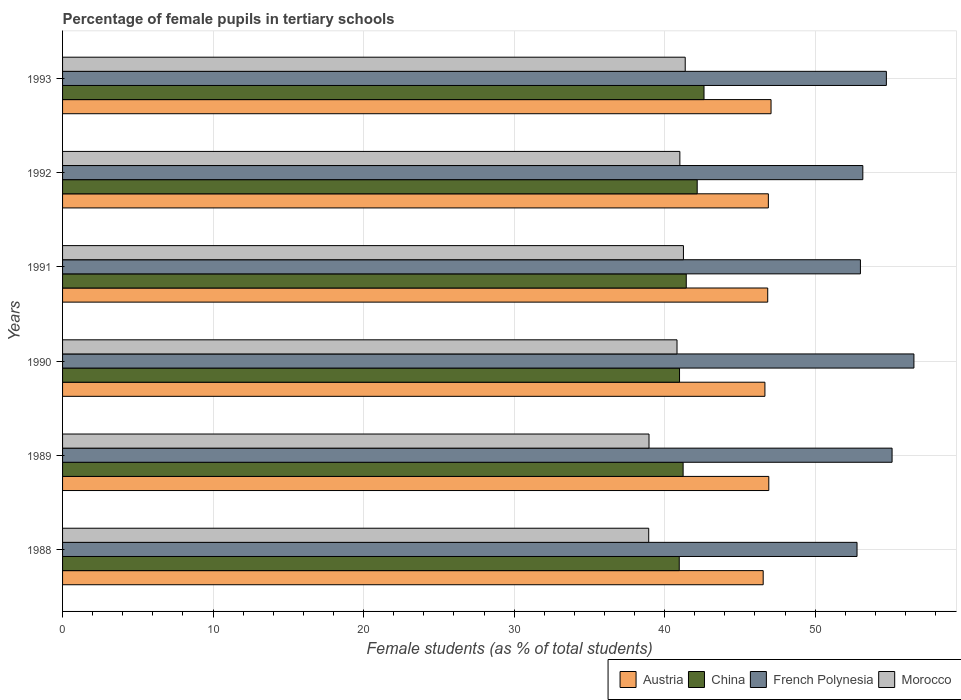Are the number of bars on each tick of the Y-axis equal?
Offer a terse response. Yes. In how many cases, is the number of bars for a given year not equal to the number of legend labels?
Give a very brief answer. 0. What is the percentage of female pupils in tertiary schools in Morocco in 1993?
Keep it short and to the point. 41.37. Across all years, what is the maximum percentage of female pupils in tertiary schools in Morocco?
Give a very brief answer. 41.37. Across all years, what is the minimum percentage of female pupils in tertiary schools in French Polynesia?
Your answer should be compact. 52.78. What is the total percentage of female pupils in tertiary schools in French Polynesia in the graph?
Provide a short and direct response. 325.35. What is the difference between the percentage of female pupils in tertiary schools in Morocco in 1992 and that in 1993?
Provide a short and direct response. -0.36. What is the difference between the percentage of female pupils in tertiary schools in French Polynesia in 1993 and the percentage of female pupils in tertiary schools in Morocco in 1989?
Offer a terse response. 15.77. What is the average percentage of female pupils in tertiary schools in Morocco per year?
Your response must be concise. 40.39. In the year 1993, what is the difference between the percentage of female pupils in tertiary schools in Morocco and percentage of female pupils in tertiary schools in Austria?
Make the answer very short. -5.7. In how many years, is the percentage of female pupils in tertiary schools in Austria greater than 2 %?
Offer a terse response. 6. What is the ratio of the percentage of female pupils in tertiary schools in China in 1992 to that in 1993?
Your answer should be very brief. 0.99. Is the percentage of female pupils in tertiary schools in French Polynesia in 1989 less than that in 1990?
Provide a short and direct response. Yes. What is the difference between the highest and the second highest percentage of female pupils in tertiary schools in Austria?
Offer a very short reply. 0.15. What is the difference between the highest and the lowest percentage of female pupils in tertiary schools in Morocco?
Offer a very short reply. 2.43. In how many years, is the percentage of female pupils in tertiary schools in Morocco greater than the average percentage of female pupils in tertiary schools in Morocco taken over all years?
Give a very brief answer. 4. Is the sum of the percentage of female pupils in tertiary schools in French Polynesia in 1989 and 1993 greater than the maximum percentage of female pupils in tertiary schools in Morocco across all years?
Give a very brief answer. Yes. What does the 1st bar from the top in 1993 represents?
Ensure brevity in your answer.  Morocco. What does the 4th bar from the bottom in 1988 represents?
Provide a short and direct response. Morocco. Are all the bars in the graph horizontal?
Your response must be concise. Yes. How many years are there in the graph?
Offer a terse response. 6. What is the difference between two consecutive major ticks on the X-axis?
Provide a succinct answer. 10. Are the values on the major ticks of X-axis written in scientific E-notation?
Provide a succinct answer. No. How are the legend labels stacked?
Your answer should be compact. Horizontal. What is the title of the graph?
Make the answer very short. Percentage of female pupils in tertiary schools. Does "Burkina Faso" appear as one of the legend labels in the graph?
Keep it short and to the point. No. What is the label or title of the X-axis?
Make the answer very short. Female students (as % of total students). What is the Female students (as % of total students) of Austria in 1988?
Your answer should be very brief. 46.55. What is the Female students (as % of total students) in China in 1988?
Offer a very short reply. 40.97. What is the Female students (as % of total students) of French Polynesia in 1988?
Ensure brevity in your answer.  52.78. What is the Female students (as % of total students) of Morocco in 1988?
Ensure brevity in your answer.  38.94. What is the Female students (as % of total students) in Austria in 1989?
Give a very brief answer. 46.92. What is the Female students (as % of total students) in China in 1989?
Make the answer very short. 41.23. What is the Female students (as % of total students) of French Polynesia in 1989?
Ensure brevity in your answer.  55.11. What is the Female students (as % of total students) in Morocco in 1989?
Your response must be concise. 38.96. What is the Female students (as % of total students) in Austria in 1990?
Make the answer very short. 46.66. What is the Female students (as % of total students) of China in 1990?
Provide a succinct answer. 40.99. What is the Female students (as % of total students) in French Polynesia in 1990?
Provide a short and direct response. 56.56. What is the Female students (as % of total students) of Morocco in 1990?
Make the answer very short. 40.82. What is the Female students (as % of total students) in Austria in 1991?
Your answer should be compact. 46.85. What is the Female students (as % of total students) in China in 1991?
Give a very brief answer. 41.44. What is the Female students (as % of total students) of French Polynesia in 1991?
Your answer should be very brief. 53.01. What is the Female students (as % of total students) in Morocco in 1991?
Your answer should be very brief. 41.25. What is the Female students (as % of total students) of Austria in 1992?
Give a very brief answer. 46.89. What is the Female students (as % of total students) in China in 1992?
Offer a terse response. 42.16. What is the Female students (as % of total students) of French Polynesia in 1992?
Provide a succinct answer. 53.17. What is the Female students (as % of total students) of Morocco in 1992?
Ensure brevity in your answer.  41.01. What is the Female students (as % of total students) of Austria in 1993?
Provide a short and direct response. 47.07. What is the Female students (as % of total students) of China in 1993?
Keep it short and to the point. 42.62. What is the Female students (as % of total students) of French Polynesia in 1993?
Ensure brevity in your answer.  54.73. What is the Female students (as % of total students) of Morocco in 1993?
Your response must be concise. 41.37. Across all years, what is the maximum Female students (as % of total students) in Austria?
Your answer should be very brief. 47.07. Across all years, what is the maximum Female students (as % of total students) in China?
Give a very brief answer. 42.62. Across all years, what is the maximum Female students (as % of total students) in French Polynesia?
Offer a terse response. 56.56. Across all years, what is the maximum Female students (as % of total students) in Morocco?
Provide a succinct answer. 41.37. Across all years, what is the minimum Female students (as % of total students) in Austria?
Make the answer very short. 46.55. Across all years, what is the minimum Female students (as % of total students) in China?
Provide a short and direct response. 40.97. Across all years, what is the minimum Female students (as % of total students) in French Polynesia?
Provide a succinct answer. 52.78. Across all years, what is the minimum Female students (as % of total students) in Morocco?
Your answer should be very brief. 38.94. What is the total Female students (as % of total students) in Austria in the graph?
Your answer should be very brief. 280.93. What is the total Female students (as % of total students) in China in the graph?
Your answer should be very brief. 249.4. What is the total Female students (as % of total students) in French Polynesia in the graph?
Keep it short and to the point. 325.35. What is the total Female students (as % of total students) of Morocco in the graph?
Keep it short and to the point. 242.35. What is the difference between the Female students (as % of total students) in Austria in 1988 and that in 1989?
Provide a succinct answer. -0.37. What is the difference between the Female students (as % of total students) of China in 1988 and that in 1989?
Make the answer very short. -0.26. What is the difference between the Female students (as % of total students) of French Polynesia in 1988 and that in 1989?
Give a very brief answer. -2.33. What is the difference between the Female students (as % of total students) in Morocco in 1988 and that in 1989?
Keep it short and to the point. -0.02. What is the difference between the Female students (as % of total students) of Austria in 1988 and that in 1990?
Your response must be concise. -0.11. What is the difference between the Female students (as % of total students) of China in 1988 and that in 1990?
Provide a short and direct response. -0.02. What is the difference between the Female students (as % of total students) of French Polynesia in 1988 and that in 1990?
Offer a very short reply. -3.78. What is the difference between the Female students (as % of total students) in Morocco in 1988 and that in 1990?
Ensure brevity in your answer.  -1.88. What is the difference between the Female students (as % of total students) of Austria in 1988 and that in 1991?
Ensure brevity in your answer.  -0.3. What is the difference between the Female students (as % of total students) of China in 1988 and that in 1991?
Give a very brief answer. -0.47. What is the difference between the Female students (as % of total students) of French Polynesia in 1988 and that in 1991?
Provide a succinct answer. -0.22. What is the difference between the Female students (as % of total students) in Morocco in 1988 and that in 1991?
Keep it short and to the point. -2.31. What is the difference between the Female students (as % of total students) in Austria in 1988 and that in 1992?
Your response must be concise. -0.34. What is the difference between the Female students (as % of total students) in China in 1988 and that in 1992?
Give a very brief answer. -1.19. What is the difference between the Female students (as % of total students) of French Polynesia in 1988 and that in 1992?
Make the answer very short. -0.39. What is the difference between the Female students (as % of total students) of Morocco in 1988 and that in 1992?
Give a very brief answer. -2.07. What is the difference between the Female students (as % of total students) in Austria in 1988 and that in 1993?
Ensure brevity in your answer.  -0.52. What is the difference between the Female students (as % of total students) in China in 1988 and that in 1993?
Offer a very short reply. -1.65. What is the difference between the Female students (as % of total students) of French Polynesia in 1988 and that in 1993?
Give a very brief answer. -1.95. What is the difference between the Female students (as % of total students) in Morocco in 1988 and that in 1993?
Offer a very short reply. -2.43. What is the difference between the Female students (as % of total students) in Austria in 1989 and that in 1990?
Ensure brevity in your answer.  0.26. What is the difference between the Female students (as % of total students) of China in 1989 and that in 1990?
Provide a succinct answer. 0.24. What is the difference between the Female students (as % of total students) of French Polynesia in 1989 and that in 1990?
Your answer should be compact. -1.45. What is the difference between the Female students (as % of total students) of Morocco in 1989 and that in 1990?
Give a very brief answer. -1.86. What is the difference between the Female students (as % of total students) in Austria in 1989 and that in 1991?
Your answer should be very brief. 0.07. What is the difference between the Female students (as % of total students) in China in 1989 and that in 1991?
Offer a terse response. -0.21. What is the difference between the Female students (as % of total students) in French Polynesia in 1989 and that in 1991?
Your answer should be very brief. 2.1. What is the difference between the Female students (as % of total students) in Morocco in 1989 and that in 1991?
Your answer should be very brief. -2.29. What is the difference between the Female students (as % of total students) of Austria in 1989 and that in 1992?
Your answer should be very brief. 0.03. What is the difference between the Female students (as % of total students) of China in 1989 and that in 1992?
Offer a very short reply. -0.94. What is the difference between the Female students (as % of total students) in French Polynesia in 1989 and that in 1992?
Keep it short and to the point. 1.94. What is the difference between the Female students (as % of total students) in Morocco in 1989 and that in 1992?
Give a very brief answer. -2.05. What is the difference between the Female students (as % of total students) in Austria in 1989 and that in 1993?
Keep it short and to the point. -0.15. What is the difference between the Female students (as % of total students) of China in 1989 and that in 1993?
Provide a succinct answer. -1.39. What is the difference between the Female students (as % of total students) of French Polynesia in 1989 and that in 1993?
Ensure brevity in your answer.  0.38. What is the difference between the Female students (as % of total students) of Morocco in 1989 and that in 1993?
Keep it short and to the point. -2.4. What is the difference between the Female students (as % of total students) of Austria in 1990 and that in 1991?
Ensure brevity in your answer.  -0.19. What is the difference between the Female students (as % of total students) of China in 1990 and that in 1991?
Your answer should be very brief. -0.45. What is the difference between the Female students (as % of total students) in French Polynesia in 1990 and that in 1991?
Provide a succinct answer. 3.55. What is the difference between the Female students (as % of total students) of Morocco in 1990 and that in 1991?
Provide a succinct answer. -0.43. What is the difference between the Female students (as % of total students) in Austria in 1990 and that in 1992?
Give a very brief answer. -0.23. What is the difference between the Female students (as % of total students) of China in 1990 and that in 1992?
Your response must be concise. -1.17. What is the difference between the Female students (as % of total students) in French Polynesia in 1990 and that in 1992?
Give a very brief answer. 3.39. What is the difference between the Female students (as % of total students) of Morocco in 1990 and that in 1992?
Offer a very short reply. -0.19. What is the difference between the Female students (as % of total students) in Austria in 1990 and that in 1993?
Provide a short and direct response. -0.41. What is the difference between the Female students (as % of total students) of China in 1990 and that in 1993?
Give a very brief answer. -1.63. What is the difference between the Female students (as % of total students) of French Polynesia in 1990 and that in 1993?
Make the answer very short. 1.83. What is the difference between the Female students (as % of total students) in Morocco in 1990 and that in 1993?
Provide a succinct answer. -0.54. What is the difference between the Female students (as % of total students) in Austria in 1991 and that in 1992?
Offer a very short reply. -0.04. What is the difference between the Female students (as % of total students) of China in 1991 and that in 1992?
Make the answer very short. -0.73. What is the difference between the Female students (as % of total students) of French Polynesia in 1991 and that in 1992?
Offer a terse response. -0.16. What is the difference between the Female students (as % of total students) of Morocco in 1991 and that in 1992?
Your answer should be very brief. 0.24. What is the difference between the Female students (as % of total students) in Austria in 1991 and that in 1993?
Your response must be concise. -0.22. What is the difference between the Female students (as % of total students) in China in 1991 and that in 1993?
Offer a very short reply. -1.18. What is the difference between the Female students (as % of total students) of French Polynesia in 1991 and that in 1993?
Make the answer very short. -1.72. What is the difference between the Female students (as % of total students) in Morocco in 1991 and that in 1993?
Your answer should be compact. -0.12. What is the difference between the Female students (as % of total students) in Austria in 1992 and that in 1993?
Provide a short and direct response. -0.18. What is the difference between the Female students (as % of total students) in China in 1992 and that in 1993?
Offer a terse response. -0.45. What is the difference between the Female students (as % of total students) in French Polynesia in 1992 and that in 1993?
Your answer should be very brief. -1.56. What is the difference between the Female students (as % of total students) in Morocco in 1992 and that in 1993?
Ensure brevity in your answer.  -0.36. What is the difference between the Female students (as % of total students) in Austria in 1988 and the Female students (as % of total students) in China in 1989?
Provide a short and direct response. 5.32. What is the difference between the Female students (as % of total students) of Austria in 1988 and the Female students (as % of total students) of French Polynesia in 1989?
Your answer should be very brief. -8.56. What is the difference between the Female students (as % of total students) in Austria in 1988 and the Female students (as % of total students) in Morocco in 1989?
Offer a terse response. 7.58. What is the difference between the Female students (as % of total students) of China in 1988 and the Female students (as % of total students) of French Polynesia in 1989?
Offer a terse response. -14.14. What is the difference between the Female students (as % of total students) of China in 1988 and the Female students (as % of total students) of Morocco in 1989?
Offer a terse response. 2.01. What is the difference between the Female students (as % of total students) in French Polynesia in 1988 and the Female students (as % of total students) in Morocco in 1989?
Your answer should be compact. 13.82. What is the difference between the Female students (as % of total students) in Austria in 1988 and the Female students (as % of total students) in China in 1990?
Give a very brief answer. 5.56. What is the difference between the Female students (as % of total students) in Austria in 1988 and the Female students (as % of total students) in French Polynesia in 1990?
Keep it short and to the point. -10.01. What is the difference between the Female students (as % of total students) in Austria in 1988 and the Female students (as % of total students) in Morocco in 1990?
Provide a short and direct response. 5.72. What is the difference between the Female students (as % of total students) in China in 1988 and the Female students (as % of total students) in French Polynesia in 1990?
Provide a succinct answer. -15.59. What is the difference between the Female students (as % of total students) in China in 1988 and the Female students (as % of total students) in Morocco in 1990?
Give a very brief answer. 0.15. What is the difference between the Female students (as % of total students) of French Polynesia in 1988 and the Female students (as % of total students) of Morocco in 1990?
Give a very brief answer. 11.96. What is the difference between the Female students (as % of total students) in Austria in 1988 and the Female students (as % of total students) in China in 1991?
Give a very brief answer. 5.11. What is the difference between the Female students (as % of total students) of Austria in 1988 and the Female students (as % of total students) of French Polynesia in 1991?
Your response must be concise. -6.46. What is the difference between the Female students (as % of total students) in Austria in 1988 and the Female students (as % of total students) in Morocco in 1991?
Make the answer very short. 5.3. What is the difference between the Female students (as % of total students) of China in 1988 and the Female students (as % of total students) of French Polynesia in 1991?
Your answer should be very brief. -12.04. What is the difference between the Female students (as % of total students) of China in 1988 and the Female students (as % of total students) of Morocco in 1991?
Offer a very short reply. -0.28. What is the difference between the Female students (as % of total students) of French Polynesia in 1988 and the Female students (as % of total students) of Morocco in 1991?
Ensure brevity in your answer.  11.53. What is the difference between the Female students (as % of total students) of Austria in 1988 and the Female students (as % of total students) of China in 1992?
Offer a very short reply. 4.38. What is the difference between the Female students (as % of total students) in Austria in 1988 and the Female students (as % of total students) in French Polynesia in 1992?
Provide a succinct answer. -6.62. What is the difference between the Female students (as % of total students) of Austria in 1988 and the Female students (as % of total students) of Morocco in 1992?
Offer a terse response. 5.54. What is the difference between the Female students (as % of total students) of China in 1988 and the Female students (as % of total students) of French Polynesia in 1992?
Give a very brief answer. -12.2. What is the difference between the Female students (as % of total students) in China in 1988 and the Female students (as % of total students) in Morocco in 1992?
Make the answer very short. -0.04. What is the difference between the Female students (as % of total students) in French Polynesia in 1988 and the Female students (as % of total students) in Morocco in 1992?
Provide a short and direct response. 11.77. What is the difference between the Female students (as % of total students) in Austria in 1988 and the Female students (as % of total students) in China in 1993?
Provide a succinct answer. 3.93. What is the difference between the Female students (as % of total students) of Austria in 1988 and the Female students (as % of total students) of French Polynesia in 1993?
Provide a short and direct response. -8.18. What is the difference between the Female students (as % of total students) of Austria in 1988 and the Female students (as % of total students) of Morocco in 1993?
Ensure brevity in your answer.  5.18. What is the difference between the Female students (as % of total students) in China in 1988 and the Female students (as % of total students) in French Polynesia in 1993?
Your answer should be compact. -13.76. What is the difference between the Female students (as % of total students) of China in 1988 and the Female students (as % of total students) of Morocco in 1993?
Give a very brief answer. -0.4. What is the difference between the Female students (as % of total students) in French Polynesia in 1988 and the Female students (as % of total students) in Morocco in 1993?
Your answer should be very brief. 11.41. What is the difference between the Female students (as % of total students) in Austria in 1989 and the Female students (as % of total students) in China in 1990?
Give a very brief answer. 5.93. What is the difference between the Female students (as % of total students) in Austria in 1989 and the Female students (as % of total students) in French Polynesia in 1990?
Provide a short and direct response. -9.64. What is the difference between the Female students (as % of total students) in Austria in 1989 and the Female students (as % of total students) in Morocco in 1990?
Provide a succinct answer. 6.1. What is the difference between the Female students (as % of total students) in China in 1989 and the Female students (as % of total students) in French Polynesia in 1990?
Offer a terse response. -15.33. What is the difference between the Female students (as % of total students) in China in 1989 and the Female students (as % of total students) in Morocco in 1990?
Ensure brevity in your answer.  0.41. What is the difference between the Female students (as % of total students) in French Polynesia in 1989 and the Female students (as % of total students) in Morocco in 1990?
Give a very brief answer. 14.29. What is the difference between the Female students (as % of total students) of Austria in 1989 and the Female students (as % of total students) of China in 1991?
Your response must be concise. 5.48. What is the difference between the Female students (as % of total students) of Austria in 1989 and the Female students (as % of total students) of French Polynesia in 1991?
Ensure brevity in your answer.  -6.09. What is the difference between the Female students (as % of total students) of Austria in 1989 and the Female students (as % of total students) of Morocco in 1991?
Make the answer very short. 5.67. What is the difference between the Female students (as % of total students) of China in 1989 and the Female students (as % of total students) of French Polynesia in 1991?
Give a very brief answer. -11.78. What is the difference between the Female students (as % of total students) of China in 1989 and the Female students (as % of total students) of Morocco in 1991?
Provide a short and direct response. -0.02. What is the difference between the Female students (as % of total students) in French Polynesia in 1989 and the Female students (as % of total students) in Morocco in 1991?
Offer a terse response. 13.86. What is the difference between the Female students (as % of total students) of Austria in 1989 and the Female students (as % of total students) of China in 1992?
Your answer should be very brief. 4.76. What is the difference between the Female students (as % of total students) of Austria in 1989 and the Female students (as % of total students) of French Polynesia in 1992?
Offer a terse response. -6.25. What is the difference between the Female students (as % of total students) of Austria in 1989 and the Female students (as % of total students) of Morocco in 1992?
Your answer should be compact. 5.91. What is the difference between the Female students (as % of total students) in China in 1989 and the Female students (as % of total students) in French Polynesia in 1992?
Your response must be concise. -11.94. What is the difference between the Female students (as % of total students) in China in 1989 and the Female students (as % of total students) in Morocco in 1992?
Offer a terse response. 0.22. What is the difference between the Female students (as % of total students) in French Polynesia in 1989 and the Female students (as % of total students) in Morocco in 1992?
Offer a very short reply. 14.1. What is the difference between the Female students (as % of total students) in Austria in 1989 and the Female students (as % of total students) in China in 1993?
Provide a short and direct response. 4.3. What is the difference between the Female students (as % of total students) of Austria in 1989 and the Female students (as % of total students) of French Polynesia in 1993?
Provide a short and direct response. -7.81. What is the difference between the Female students (as % of total students) in Austria in 1989 and the Female students (as % of total students) in Morocco in 1993?
Offer a terse response. 5.55. What is the difference between the Female students (as % of total students) of China in 1989 and the Female students (as % of total students) of French Polynesia in 1993?
Your answer should be compact. -13.5. What is the difference between the Female students (as % of total students) of China in 1989 and the Female students (as % of total students) of Morocco in 1993?
Give a very brief answer. -0.14. What is the difference between the Female students (as % of total students) in French Polynesia in 1989 and the Female students (as % of total students) in Morocco in 1993?
Your answer should be very brief. 13.74. What is the difference between the Female students (as % of total students) of Austria in 1990 and the Female students (as % of total students) of China in 1991?
Your answer should be very brief. 5.23. What is the difference between the Female students (as % of total students) of Austria in 1990 and the Female students (as % of total students) of French Polynesia in 1991?
Provide a short and direct response. -6.34. What is the difference between the Female students (as % of total students) of Austria in 1990 and the Female students (as % of total students) of Morocco in 1991?
Your response must be concise. 5.41. What is the difference between the Female students (as % of total students) of China in 1990 and the Female students (as % of total students) of French Polynesia in 1991?
Your answer should be very brief. -12.02. What is the difference between the Female students (as % of total students) of China in 1990 and the Female students (as % of total students) of Morocco in 1991?
Offer a terse response. -0.26. What is the difference between the Female students (as % of total students) of French Polynesia in 1990 and the Female students (as % of total students) of Morocco in 1991?
Your response must be concise. 15.31. What is the difference between the Female students (as % of total students) in Austria in 1990 and the Female students (as % of total students) in China in 1992?
Offer a very short reply. 4.5. What is the difference between the Female students (as % of total students) of Austria in 1990 and the Female students (as % of total students) of French Polynesia in 1992?
Provide a short and direct response. -6.5. What is the difference between the Female students (as % of total students) of Austria in 1990 and the Female students (as % of total students) of Morocco in 1992?
Your answer should be very brief. 5.65. What is the difference between the Female students (as % of total students) of China in 1990 and the Female students (as % of total students) of French Polynesia in 1992?
Provide a short and direct response. -12.18. What is the difference between the Female students (as % of total students) in China in 1990 and the Female students (as % of total students) in Morocco in 1992?
Your response must be concise. -0.02. What is the difference between the Female students (as % of total students) of French Polynesia in 1990 and the Female students (as % of total students) of Morocco in 1992?
Provide a succinct answer. 15.55. What is the difference between the Female students (as % of total students) of Austria in 1990 and the Female students (as % of total students) of China in 1993?
Your answer should be very brief. 4.05. What is the difference between the Female students (as % of total students) of Austria in 1990 and the Female students (as % of total students) of French Polynesia in 1993?
Keep it short and to the point. -8.07. What is the difference between the Female students (as % of total students) of Austria in 1990 and the Female students (as % of total students) of Morocco in 1993?
Ensure brevity in your answer.  5.29. What is the difference between the Female students (as % of total students) in China in 1990 and the Female students (as % of total students) in French Polynesia in 1993?
Offer a very short reply. -13.74. What is the difference between the Female students (as % of total students) of China in 1990 and the Female students (as % of total students) of Morocco in 1993?
Your answer should be very brief. -0.38. What is the difference between the Female students (as % of total students) of French Polynesia in 1990 and the Female students (as % of total students) of Morocco in 1993?
Your response must be concise. 15.19. What is the difference between the Female students (as % of total students) of Austria in 1991 and the Female students (as % of total students) of China in 1992?
Offer a very short reply. 4.69. What is the difference between the Female students (as % of total students) in Austria in 1991 and the Female students (as % of total students) in French Polynesia in 1992?
Give a very brief answer. -6.32. What is the difference between the Female students (as % of total students) in Austria in 1991 and the Female students (as % of total students) in Morocco in 1992?
Provide a succinct answer. 5.84. What is the difference between the Female students (as % of total students) of China in 1991 and the Female students (as % of total students) of French Polynesia in 1992?
Your response must be concise. -11.73. What is the difference between the Female students (as % of total students) in China in 1991 and the Female students (as % of total students) in Morocco in 1992?
Provide a succinct answer. 0.43. What is the difference between the Female students (as % of total students) of French Polynesia in 1991 and the Female students (as % of total students) of Morocco in 1992?
Give a very brief answer. 12. What is the difference between the Female students (as % of total students) of Austria in 1991 and the Female students (as % of total students) of China in 1993?
Your response must be concise. 4.23. What is the difference between the Female students (as % of total students) in Austria in 1991 and the Female students (as % of total students) in French Polynesia in 1993?
Make the answer very short. -7.88. What is the difference between the Female students (as % of total students) of Austria in 1991 and the Female students (as % of total students) of Morocco in 1993?
Your response must be concise. 5.48. What is the difference between the Female students (as % of total students) of China in 1991 and the Female students (as % of total students) of French Polynesia in 1993?
Offer a very short reply. -13.29. What is the difference between the Female students (as % of total students) in China in 1991 and the Female students (as % of total students) in Morocco in 1993?
Your answer should be very brief. 0.07. What is the difference between the Female students (as % of total students) of French Polynesia in 1991 and the Female students (as % of total students) of Morocco in 1993?
Make the answer very short. 11.64. What is the difference between the Female students (as % of total students) in Austria in 1992 and the Female students (as % of total students) in China in 1993?
Your answer should be very brief. 4.27. What is the difference between the Female students (as % of total students) in Austria in 1992 and the Female students (as % of total students) in French Polynesia in 1993?
Your answer should be compact. -7.84. What is the difference between the Female students (as % of total students) of Austria in 1992 and the Female students (as % of total students) of Morocco in 1993?
Your response must be concise. 5.52. What is the difference between the Female students (as % of total students) of China in 1992 and the Female students (as % of total students) of French Polynesia in 1993?
Your answer should be compact. -12.57. What is the difference between the Female students (as % of total students) in China in 1992 and the Female students (as % of total students) in Morocco in 1993?
Make the answer very short. 0.8. What is the difference between the Female students (as % of total students) of French Polynesia in 1992 and the Female students (as % of total students) of Morocco in 1993?
Provide a short and direct response. 11.8. What is the average Female students (as % of total students) in Austria per year?
Keep it short and to the point. 46.82. What is the average Female students (as % of total students) of China per year?
Your response must be concise. 41.57. What is the average Female students (as % of total students) in French Polynesia per year?
Offer a very short reply. 54.23. What is the average Female students (as % of total students) of Morocco per year?
Provide a short and direct response. 40.39. In the year 1988, what is the difference between the Female students (as % of total students) in Austria and Female students (as % of total students) in China?
Give a very brief answer. 5.58. In the year 1988, what is the difference between the Female students (as % of total students) of Austria and Female students (as % of total students) of French Polynesia?
Keep it short and to the point. -6.23. In the year 1988, what is the difference between the Female students (as % of total students) of Austria and Female students (as % of total students) of Morocco?
Provide a succinct answer. 7.61. In the year 1988, what is the difference between the Female students (as % of total students) of China and Female students (as % of total students) of French Polynesia?
Your answer should be compact. -11.81. In the year 1988, what is the difference between the Female students (as % of total students) in China and Female students (as % of total students) in Morocco?
Your response must be concise. 2.03. In the year 1988, what is the difference between the Female students (as % of total students) of French Polynesia and Female students (as % of total students) of Morocco?
Keep it short and to the point. 13.84. In the year 1989, what is the difference between the Female students (as % of total students) in Austria and Female students (as % of total students) in China?
Your response must be concise. 5.69. In the year 1989, what is the difference between the Female students (as % of total students) of Austria and Female students (as % of total students) of French Polynesia?
Provide a short and direct response. -8.19. In the year 1989, what is the difference between the Female students (as % of total students) in Austria and Female students (as % of total students) in Morocco?
Your response must be concise. 7.96. In the year 1989, what is the difference between the Female students (as % of total students) in China and Female students (as % of total students) in French Polynesia?
Keep it short and to the point. -13.88. In the year 1989, what is the difference between the Female students (as % of total students) of China and Female students (as % of total students) of Morocco?
Keep it short and to the point. 2.27. In the year 1989, what is the difference between the Female students (as % of total students) of French Polynesia and Female students (as % of total students) of Morocco?
Ensure brevity in your answer.  16.15. In the year 1990, what is the difference between the Female students (as % of total students) of Austria and Female students (as % of total students) of China?
Offer a very short reply. 5.67. In the year 1990, what is the difference between the Female students (as % of total students) in Austria and Female students (as % of total students) in French Polynesia?
Offer a very short reply. -9.9. In the year 1990, what is the difference between the Female students (as % of total students) of Austria and Female students (as % of total students) of Morocco?
Your answer should be compact. 5.84. In the year 1990, what is the difference between the Female students (as % of total students) of China and Female students (as % of total students) of French Polynesia?
Keep it short and to the point. -15.57. In the year 1990, what is the difference between the Female students (as % of total students) of China and Female students (as % of total students) of Morocco?
Offer a terse response. 0.17. In the year 1990, what is the difference between the Female students (as % of total students) in French Polynesia and Female students (as % of total students) in Morocco?
Offer a terse response. 15.74. In the year 1991, what is the difference between the Female students (as % of total students) of Austria and Female students (as % of total students) of China?
Keep it short and to the point. 5.41. In the year 1991, what is the difference between the Female students (as % of total students) of Austria and Female students (as % of total students) of French Polynesia?
Make the answer very short. -6.16. In the year 1991, what is the difference between the Female students (as % of total students) of China and Female students (as % of total students) of French Polynesia?
Make the answer very short. -11.57. In the year 1991, what is the difference between the Female students (as % of total students) in China and Female students (as % of total students) in Morocco?
Keep it short and to the point. 0.19. In the year 1991, what is the difference between the Female students (as % of total students) in French Polynesia and Female students (as % of total students) in Morocco?
Give a very brief answer. 11.76. In the year 1992, what is the difference between the Female students (as % of total students) in Austria and Female students (as % of total students) in China?
Offer a terse response. 4.73. In the year 1992, what is the difference between the Female students (as % of total students) of Austria and Female students (as % of total students) of French Polynesia?
Offer a very short reply. -6.28. In the year 1992, what is the difference between the Female students (as % of total students) in Austria and Female students (as % of total students) in Morocco?
Offer a terse response. 5.88. In the year 1992, what is the difference between the Female students (as % of total students) in China and Female students (as % of total students) in French Polynesia?
Give a very brief answer. -11. In the year 1992, what is the difference between the Female students (as % of total students) in China and Female students (as % of total students) in Morocco?
Ensure brevity in your answer.  1.15. In the year 1992, what is the difference between the Female students (as % of total students) in French Polynesia and Female students (as % of total students) in Morocco?
Your answer should be very brief. 12.16. In the year 1993, what is the difference between the Female students (as % of total students) of Austria and Female students (as % of total students) of China?
Your answer should be compact. 4.45. In the year 1993, what is the difference between the Female students (as % of total students) in Austria and Female students (as % of total students) in French Polynesia?
Give a very brief answer. -7.66. In the year 1993, what is the difference between the Female students (as % of total students) of Austria and Female students (as % of total students) of Morocco?
Your answer should be compact. 5.7. In the year 1993, what is the difference between the Female students (as % of total students) in China and Female students (as % of total students) in French Polynesia?
Your answer should be very brief. -12.12. In the year 1993, what is the difference between the Female students (as % of total students) in China and Female students (as % of total students) in Morocco?
Offer a terse response. 1.25. In the year 1993, what is the difference between the Female students (as % of total students) in French Polynesia and Female students (as % of total students) in Morocco?
Give a very brief answer. 13.36. What is the ratio of the Female students (as % of total students) in French Polynesia in 1988 to that in 1989?
Provide a short and direct response. 0.96. What is the ratio of the Female students (as % of total students) in China in 1988 to that in 1990?
Make the answer very short. 1. What is the ratio of the Female students (as % of total students) of French Polynesia in 1988 to that in 1990?
Offer a very short reply. 0.93. What is the ratio of the Female students (as % of total students) of Morocco in 1988 to that in 1990?
Your response must be concise. 0.95. What is the ratio of the Female students (as % of total students) in Austria in 1988 to that in 1991?
Offer a terse response. 0.99. What is the ratio of the Female students (as % of total students) of China in 1988 to that in 1991?
Provide a succinct answer. 0.99. What is the ratio of the Female students (as % of total students) of Morocco in 1988 to that in 1991?
Ensure brevity in your answer.  0.94. What is the ratio of the Female students (as % of total students) of Austria in 1988 to that in 1992?
Keep it short and to the point. 0.99. What is the ratio of the Female students (as % of total students) in China in 1988 to that in 1992?
Your answer should be very brief. 0.97. What is the ratio of the Female students (as % of total students) in Morocco in 1988 to that in 1992?
Your response must be concise. 0.95. What is the ratio of the Female students (as % of total students) of Austria in 1988 to that in 1993?
Provide a succinct answer. 0.99. What is the ratio of the Female students (as % of total students) of China in 1988 to that in 1993?
Your response must be concise. 0.96. What is the ratio of the Female students (as % of total students) in French Polynesia in 1988 to that in 1993?
Your answer should be compact. 0.96. What is the ratio of the Female students (as % of total students) in Morocco in 1988 to that in 1993?
Your answer should be very brief. 0.94. What is the ratio of the Female students (as % of total students) in Austria in 1989 to that in 1990?
Offer a very short reply. 1.01. What is the ratio of the Female students (as % of total students) in China in 1989 to that in 1990?
Ensure brevity in your answer.  1.01. What is the ratio of the Female students (as % of total students) in French Polynesia in 1989 to that in 1990?
Provide a short and direct response. 0.97. What is the ratio of the Female students (as % of total students) of Morocco in 1989 to that in 1990?
Your response must be concise. 0.95. What is the ratio of the Female students (as % of total students) of China in 1989 to that in 1991?
Give a very brief answer. 0.99. What is the ratio of the Female students (as % of total students) in French Polynesia in 1989 to that in 1991?
Provide a short and direct response. 1.04. What is the ratio of the Female students (as % of total students) in Morocco in 1989 to that in 1991?
Offer a very short reply. 0.94. What is the ratio of the Female students (as % of total students) in China in 1989 to that in 1992?
Your answer should be compact. 0.98. What is the ratio of the Female students (as % of total students) of French Polynesia in 1989 to that in 1992?
Provide a short and direct response. 1.04. What is the ratio of the Female students (as % of total students) of Morocco in 1989 to that in 1992?
Make the answer very short. 0.95. What is the ratio of the Female students (as % of total students) in China in 1989 to that in 1993?
Your answer should be very brief. 0.97. What is the ratio of the Female students (as % of total students) in Morocco in 1989 to that in 1993?
Keep it short and to the point. 0.94. What is the ratio of the Female students (as % of total students) of Austria in 1990 to that in 1991?
Offer a terse response. 1. What is the ratio of the Female students (as % of total students) in China in 1990 to that in 1991?
Your answer should be compact. 0.99. What is the ratio of the Female students (as % of total students) in French Polynesia in 1990 to that in 1991?
Your answer should be very brief. 1.07. What is the ratio of the Female students (as % of total students) of Morocco in 1990 to that in 1991?
Make the answer very short. 0.99. What is the ratio of the Female students (as % of total students) of China in 1990 to that in 1992?
Your answer should be very brief. 0.97. What is the ratio of the Female students (as % of total students) of French Polynesia in 1990 to that in 1992?
Your response must be concise. 1.06. What is the ratio of the Female students (as % of total students) in Austria in 1990 to that in 1993?
Offer a very short reply. 0.99. What is the ratio of the Female students (as % of total students) in China in 1990 to that in 1993?
Offer a terse response. 0.96. What is the ratio of the Female students (as % of total students) of French Polynesia in 1990 to that in 1993?
Offer a very short reply. 1.03. What is the ratio of the Female students (as % of total students) of Morocco in 1990 to that in 1993?
Make the answer very short. 0.99. What is the ratio of the Female students (as % of total students) in Austria in 1991 to that in 1992?
Give a very brief answer. 1. What is the ratio of the Female students (as % of total students) of China in 1991 to that in 1992?
Provide a short and direct response. 0.98. What is the ratio of the Female students (as % of total students) of Morocco in 1991 to that in 1992?
Give a very brief answer. 1.01. What is the ratio of the Female students (as % of total students) in China in 1991 to that in 1993?
Provide a short and direct response. 0.97. What is the ratio of the Female students (as % of total students) of French Polynesia in 1991 to that in 1993?
Your response must be concise. 0.97. What is the ratio of the Female students (as % of total students) in French Polynesia in 1992 to that in 1993?
Your answer should be compact. 0.97. What is the difference between the highest and the second highest Female students (as % of total students) of Austria?
Offer a terse response. 0.15. What is the difference between the highest and the second highest Female students (as % of total students) of China?
Give a very brief answer. 0.45. What is the difference between the highest and the second highest Female students (as % of total students) of French Polynesia?
Your answer should be compact. 1.45. What is the difference between the highest and the second highest Female students (as % of total students) of Morocco?
Keep it short and to the point. 0.12. What is the difference between the highest and the lowest Female students (as % of total students) of Austria?
Your answer should be very brief. 0.52. What is the difference between the highest and the lowest Female students (as % of total students) of China?
Make the answer very short. 1.65. What is the difference between the highest and the lowest Female students (as % of total students) of French Polynesia?
Your answer should be compact. 3.78. What is the difference between the highest and the lowest Female students (as % of total students) of Morocco?
Your answer should be very brief. 2.43. 